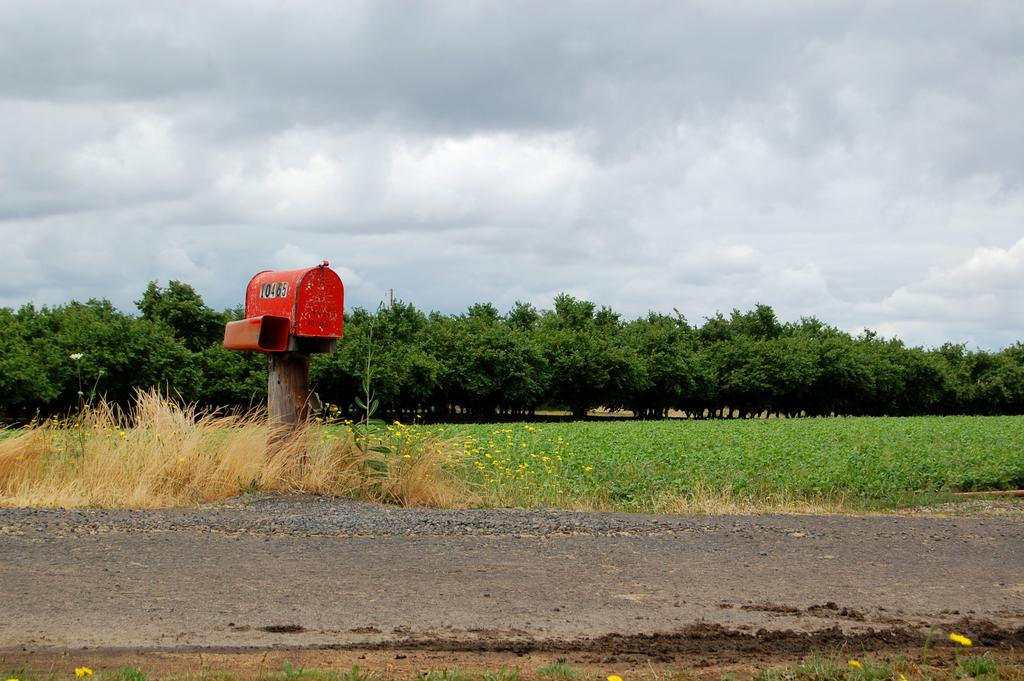What type of building is in the image? There is a post office in the image. What color is the post office? The post office is red in color. What can be seen in the background of the image? Sky, clouds, trees, grass, plants, flowers, and a road are visible in the background of the image. What type of silverware is being used by the society in the image? There is no silverware or society present in the image; it features a red post office with a background of natural elements. 